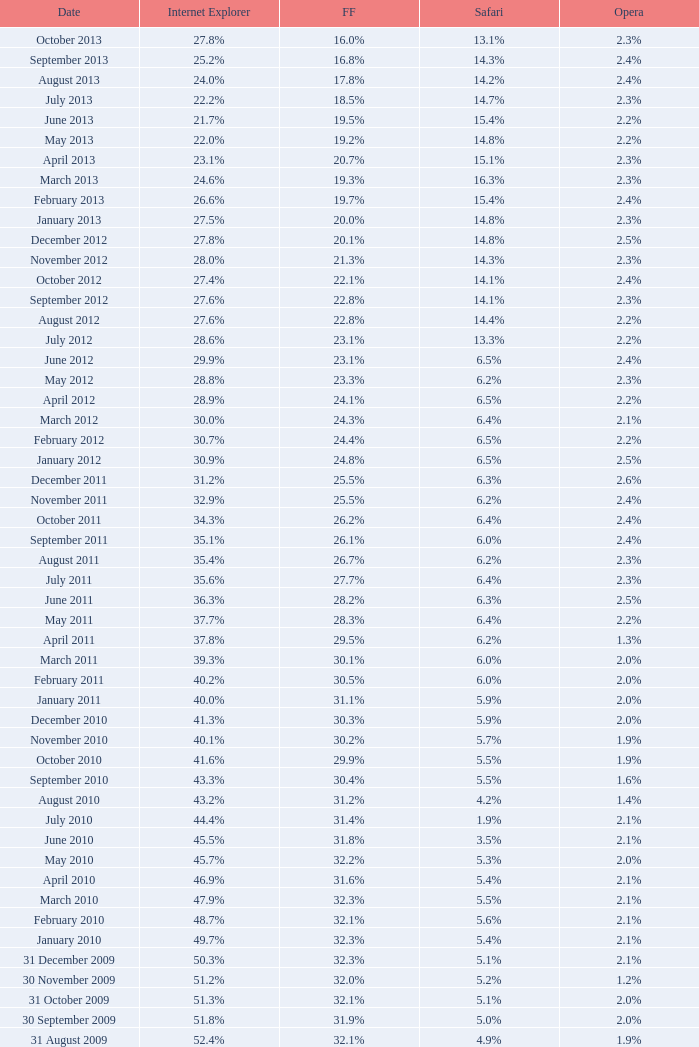What is the safari worth with a 2 14.3%. Can you give me this table as a dict? {'header': ['Date', 'Internet Explorer', 'FF', 'Safari', 'Opera'], 'rows': [['October 2013', '27.8%', '16.0%', '13.1%', '2.3%'], ['September 2013', '25.2%', '16.8%', '14.3%', '2.4%'], ['August 2013', '24.0%', '17.8%', '14.2%', '2.4%'], ['July 2013', '22.2%', '18.5%', '14.7%', '2.3%'], ['June 2013', '21.7%', '19.5%', '15.4%', '2.2%'], ['May 2013', '22.0%', '19.2%', '14.8%', '2.2%'], ['April 2013', '23.1%', '20.7%', '15.1%', '2.3%'], ['March 2013', '24.6%', '19.3%', '16.3%', '2.3%'], ['February 2013', '26.6%', '19.7%', '15.4%', '2.4%'], ['January 2013', '27.5%', '20.0%', '14.8%', '2.3%'], ['December 2012', '27.8%', '20.1%', '14.8%', '2.5%'], ['November 2012', '28.0%', '21.3%', '14.3%', '2.3%'], ['October 2012', '27.4%', '22.1%', '14.1%', '2.4%'], ['September 2012', '27.6%', '22.8%', '14.1%', '2.3%'], ['August 2012', '27.6%', '22.8%', '14.4%', '2.2%'], ['July 2012', '28.6%', '23.1%', '13.3%', '2.2%'], ['June 2012', '29.9%', '23.1%', '6.5%', '2.4%'], ['May 2012', '28.8%', '23.3%', '6.2%', '2.3%'], ['April 2012', '28.9%', '24.1%', '6.5%', '2.2%'], ['March 2012', '30.0%', '24.3%', '6.4%', '2.1%'], ['February 2012', '30.7%', '24.4%', '6.5%', '2.2%'], ['January 2012', '30.9%', '24.8%', '6.5%', '2.5%'], ['December 2011', '31.2%', '25.5%', '6.3%', '2.6%'], ['November 2011', '32.9%', '25.5%', '6.2%', '2.4%'], ['October 2011', '34.3%', '26.2%', '6.4%', '2.4%'], ['September 2011', '35.1%', '26.1%', '6.0%', '2.4%'], ['August 2011', '35.4%', '26.7%', '6.2%', '2.3%'], ['July 2011', '35.6%', '27.7%', '6.4%', '2.3%'], ['June 2011', '36.3%', '28.2%', '6.3%', '2.5%'], ['May 2011', '37.7%', '28.3%', '6.4%', '2.2%'], ['April 2011', '37.8%', '29.5%', '6.2%', '1.3%'], ['March 2011', '39.3%', '30.1%', '6.0%', '2.0%'], ['February 2011', '40.2%', '30.5%', '6.0%', '2.0%'], ['January 2011', '40.0%', '31.1%', '5.9%', '2.0%'], ['December 2010', '41.3%', '30.3%', '5.9%', '2.0%'], ['November 2010', '40.1%', '30.2%', '5.7%', '1.9%'], ['October 2010', '41.6%', '29.9%', '5.5%', '1.9%'], ['September 2010', '43.3%', '30.4%', '5.5%', '1.6%'], ['August 2010', '43.2%', '31.2%', '4.2%', '1.4%'], ['July 2010', '44.4%', '31.4%', '1.9%', '2.1%'], ['June 2010', '45.5%', '31.8%', '3.5%', '2.1%'], ['May 2010', '45.7%', '32.2%', '5.3%', '2.0%'], ['April 2010', '46.9%', '31.6%', '5.4%', '2.1%'], ['March 2010', '47.9%', '32.3%', '5.5%', '2.1%'], ['February 2010', '48.7%', '32.1%', '5.6%', '2.1%'], ['January 2010', '49.7%', '32.3%', '5.4%', '2.1%'], ['31 December 2009', '50.3%', '32.3%', '5.1%', '2.1%'], ['30 November 2009', '51.2%', '32.0%', '5.2%', '1.2%'], ['31 October 2009', '51.3%', '32.1%', '5.1%', '2.0%'], ['30 September 2009', '51.8%', '31.9%', '5.0%', '2.0%'], ['31 August 2009', '52.4%', '32.1%', '4.9%', '1.9%'], ['31 July 2009', '53.1%', '31.7%', '4.6%', '1.8%'], ['30 June 2009', '57.1%', '31.6%', '3.2%', '2.0%'], ['31 May 2009', '57.5%', '31.4%', '3.1%', '2.0%'], ['30 April 2009', '57.6%', '31.6%', '2.9%', '2.0%'], ['31 March 2009', '57.8%', '31.5%', '2.8%', '2.0%'], ['28 February 2009', '58.1%', '31.3%', '2.7%', '2.0%'], ['31 January 2009', '58.4%', '31.1%', '2.7%', '2.0%'], ['31 December 2008', '58.6%', '31.1%', '2.9%', '2.1%'], ['30 November 2008', '59.0%', '30.8%', '3.0%', '2.0%'], ['31 October 2008', '59.4%', '30.6%', '3.0%', '2.0%'], ['30 September 2008', '57.3%', '32.5%', '2.7%', '2.0%'], ['31 August 2008', '58.7%', '31.4%', '2.4%', '2.1%'], ['31 July 2008', '60.9%', '29.7%', '2.4%', '2.0%'], ['30 June 2008', '61.7%', '29.1%', '2.5%', '2.0%'], ['31 May 2008', '61.9%', '28.9%', '2.7%', '2.0%'], ['30 April 2008', '62.0%', '28.8%', '2.8%', '2.0%'], ['31 March 2008', '62.0%', '28.8%', '2.8%', '2.0%'], ['29 February 2008', '62.0%', '28.7%', '2.8%', '2.0%'], ['31 January 2008', '62.2%', '28.7%', '2.7%', '2.0%'], ['1 December 2007', '62.8%', '28.0%', '2.6%', '2.0%'], ['10 November 2007', '63.0%', '27.8%', '2.5%', '2.0%'], ['30 October 2007', '65.5%', '26.3%', '2.3%', '1.8%'], ['20 September 2007', '66.6%', '25.6%', '2.1%', '1.8%'], ['30 August 2007', '66.7%', '25.5%', '2.1%', '1.8%'], ['30 July 2007', '66.9%', '25.1%', '2.2%', '1.8%'], ['30 June 2007', '66.9%', '25.1%', '2.3%', '1.8%'], ['30 May 2007', '67.1%', '24.8%', '2.4%', '1.8%'], ['Date', 'Internet Explorer', 'Firefox', 'Safari', 'Opera']]} 